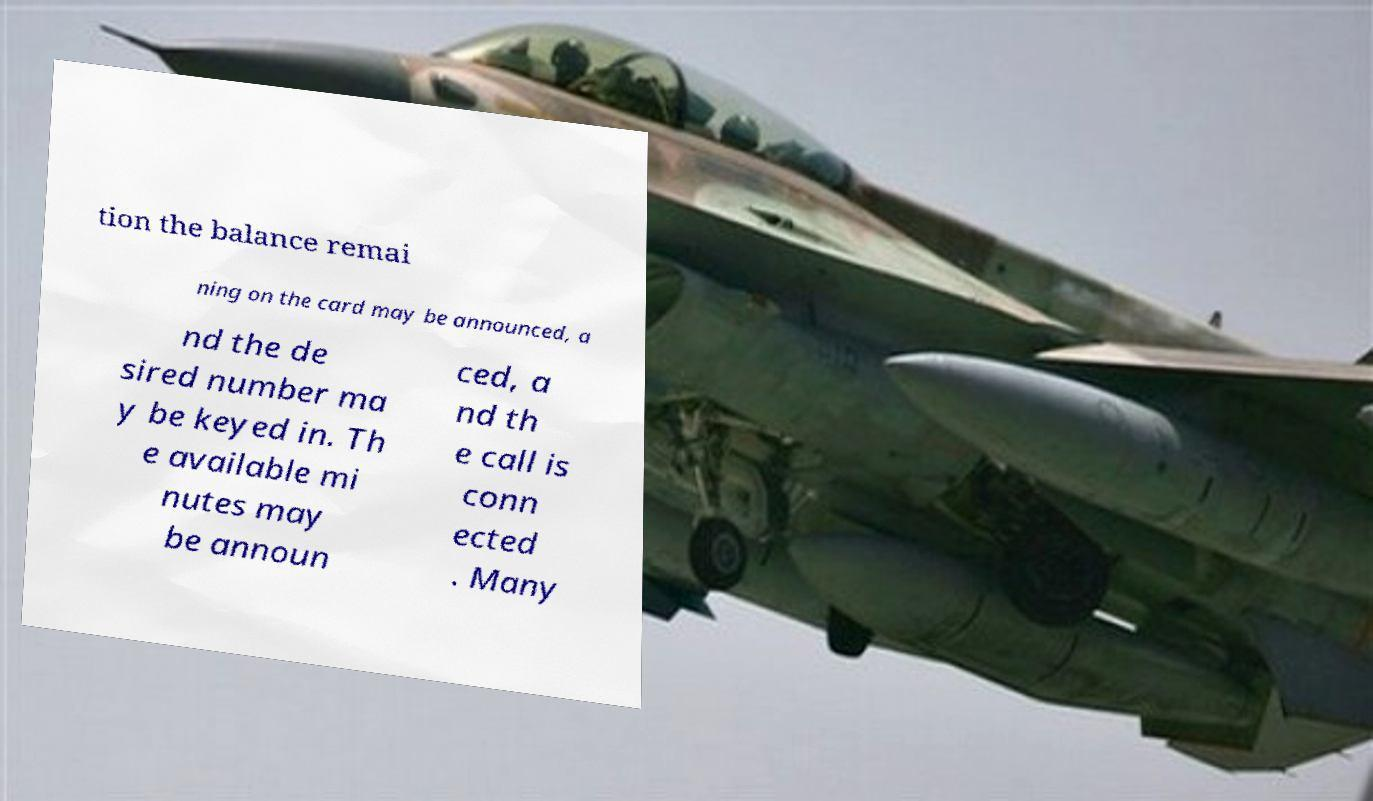There's text embedded in this image that I need extracted. Can you transcribe it verbatim? tion the balance remai ning on the card may be announced, a nd the de sired number ma y be keyed in. Th e available mi nutes may be announ ced, a nd th e call is conn ected . Many 